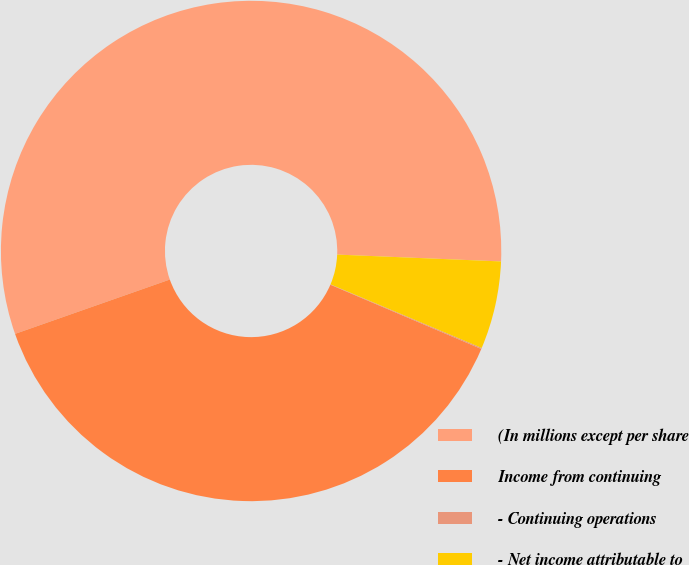<chart> <loc_0><loc_0><loc_500><loc_500><pie_chart><fcel>(In millions except per share<fcel>Income from continuing<fcel>- Continuing operations<fcel>- Net income attributable to<nl><fcel>56.04%<fcel>38.22%<fcel>0.07%<fcel>5.67%<nl></chart> 